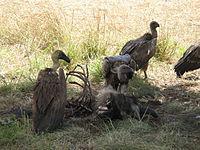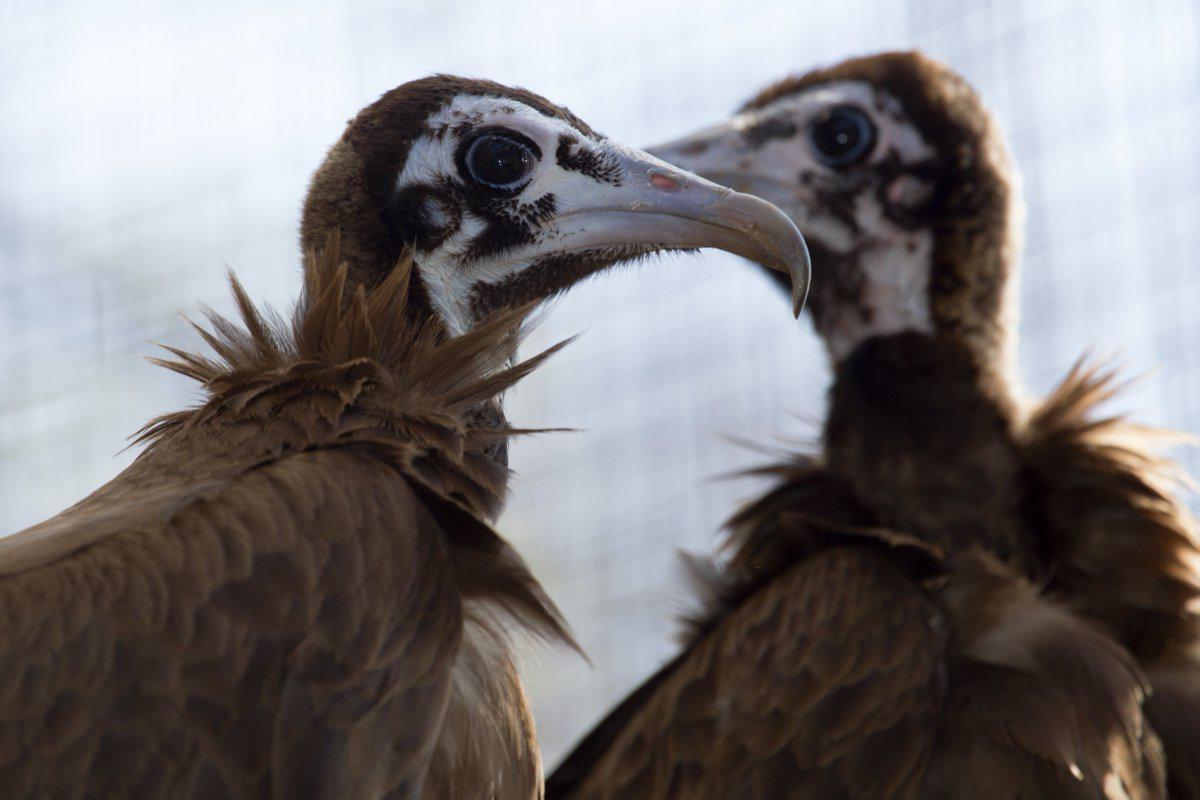The first image is the image on the left, the second image is the image on the right. Given the left and right images, does the statement "At least one of the images contains exactly one bird." hold true? Answer yes or no. No. The first image is the image on the left, the second image is the image on the right. Analyze the images presented: Is the assertion "there is exactly one bird in the image on the left" valid? Answer yes or no. No. 